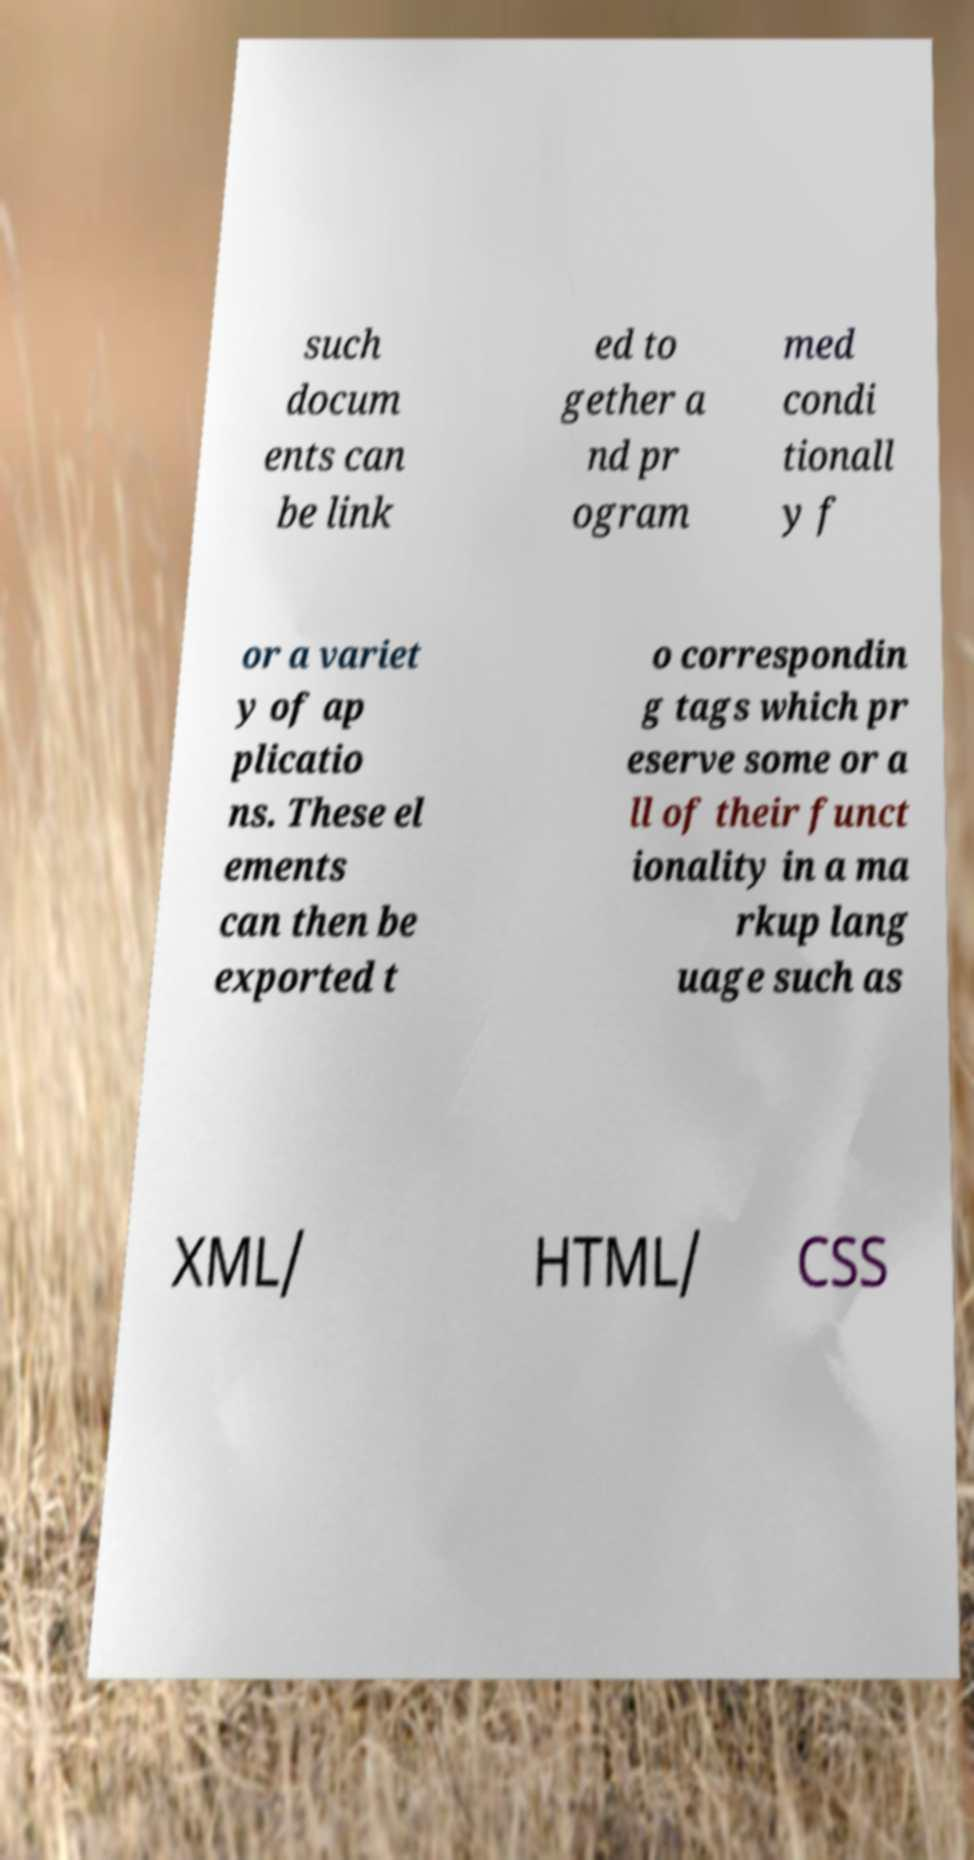Please read and relay the text visible in this image. What does it say? such docum ents can be link ed to gether a nd pr ogram med condi tionall y f or a variet y of ap plicatio ns. These el ements can then be exported t o correspondin g tags which pr eserve some or a ll of their funct ionality in a ma rkup lang uage such as XML/ HTML/ CSS 